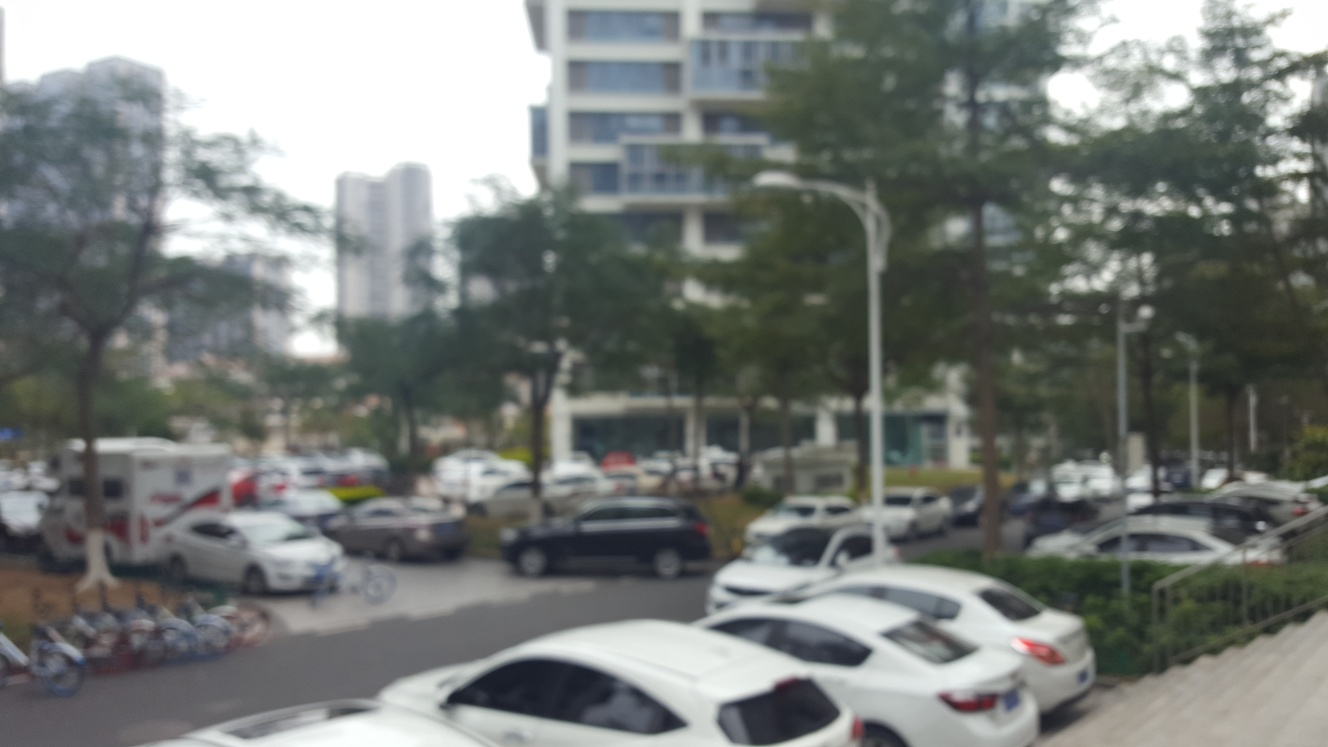Can you speculate on what might have caused this image to be so blurry? There are several possibilities that might explain the blurriness of this image. It could be due to camera movement during exposure, incorrect focus settings, or a low-quality camera lens. Additionally, it might be the result of an intentional effect to convey a sense of motion or to mimic a particular artistic style. 